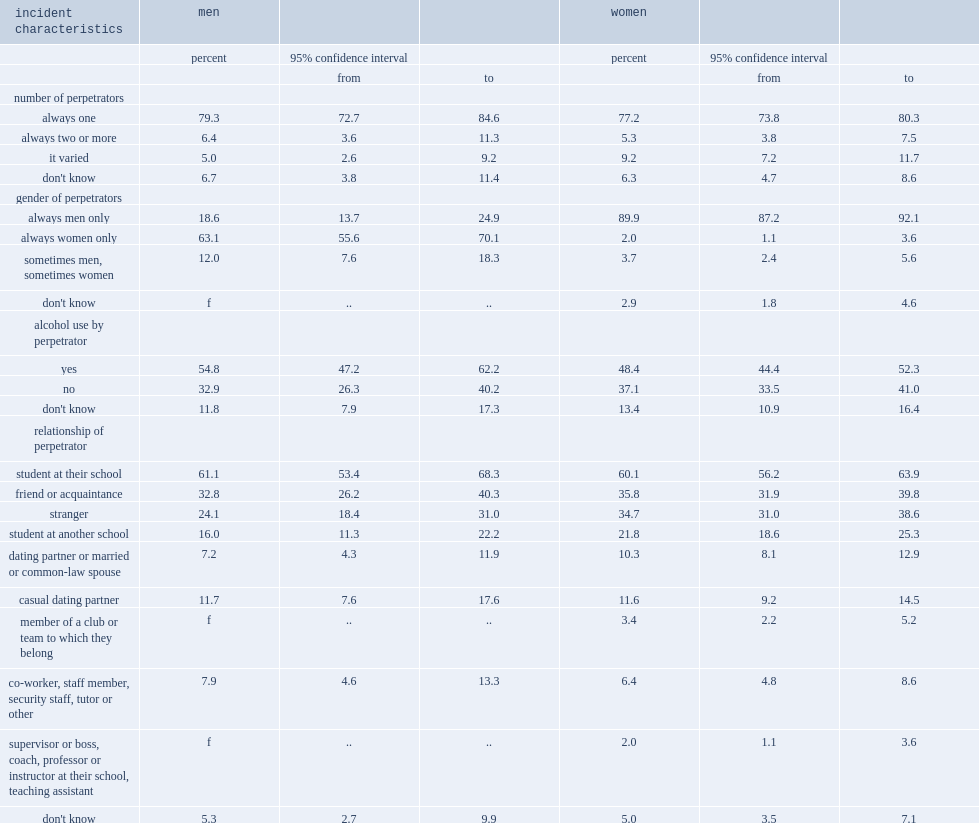How many percent of women who had been sexually assaulted in a postsecondary setting stated that each instance had involved one perpetrator? 77.2. How many percent of men who had been sexually assaulted in a postsecondary setting stated that each instance had involved one perpetrator? 79.3. What were the proportions stated that two or more people of women who had been sexually assaulted? 5.3. What were the proportions stated that two or more people of men who had been sexually assaulted? 6.4. What were the proportions varied from incident to incident of women who had been sexually assaulted? 9.2. What were the proportions varied from incident to incident of men who had been sexually assaulted? 5.0. How many percent of women who experienced at least one sexual assault in the postsecondary context said that they believed the sexual assault was related to the perpetrator's use of alcohol or drugs? 48.4. How many percent of men who experienced at least one sexual assault in the postsecondary context said that they believed the sexual assault was related to the perpetrator's use of alcohol or drugs? 54.8. Most students who had been sexually assaulted indicated that at least one incident was committed by a fellow student or students, how many percent of women who were sexually assaulted? 60.1. Most students who had been sexually assaulted indicated that at least one incident was committed by a fellow student or students, how many percent of men who were sexually assaulted? 61.1. How many percent of women students who were sexually assaulted stated that the perpetrator was someone in a position of authority such as a professor, coach, supervisor or employer? 2.0. How many percent of current or former casual dating partners were implicated of both women and men who had been sexually assaulted in the postsecondary setting? 11.6. How many percent of women said that the perpetrator was a current or former spouse, common-law partner or boyfriend or girlfriend? 10.3. How many percent of men said that the perpetrator was a current or former spouse, common-law partner or boyfriend or girlfriend? 7.2. How many percent of women indicated that men were the perpetrators in all instances of sexual assault that they experienced in a postsecondary environment? 89.9. Among men who had been sexually assaulted, how many percent stated that women were responsible in all instances? 63.1. 